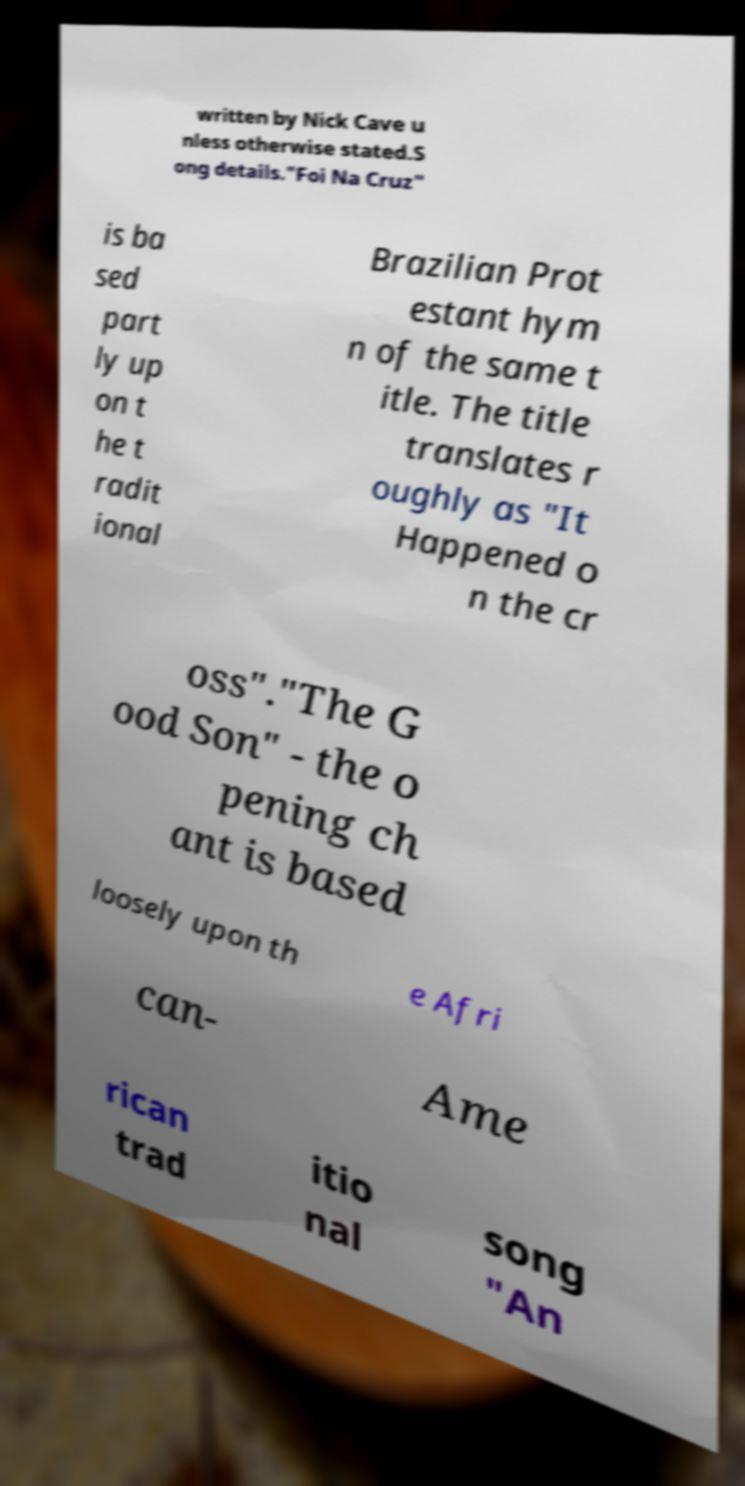Could you extract and type out the text from this image? written by Nick Cave u nless otherwise stated.S ong details."Foi Na Cruz" is ba sed part ly up on t he t radit ional Brazilian Prot estant hym n of the same t itle. The title translates r oughly as "It Happened o n the cr oss"."The G ood Son" - the o pening ch ant is based loosely upon th e Afri can- Ame rican trad itio nal song "An 